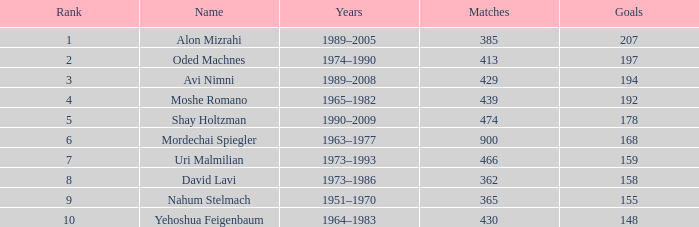What is the Rank of the player with 362 Matches? 8.0. 